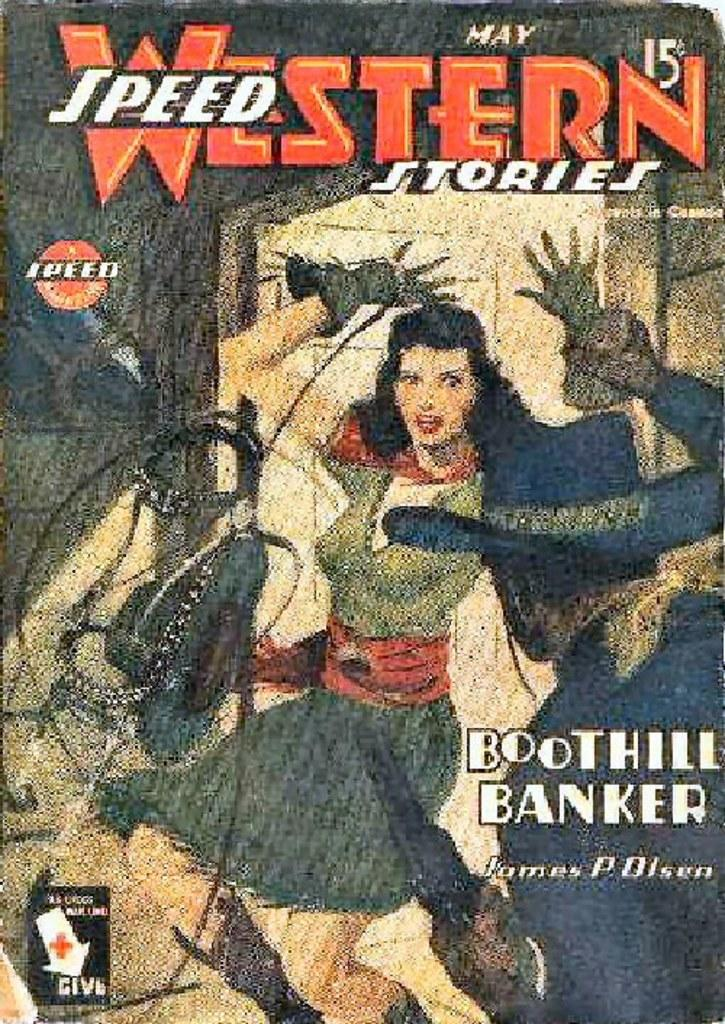<image>
Create a compact narrative representing the image presented. A May Western Speed Stories comic book cost 15 cents. 